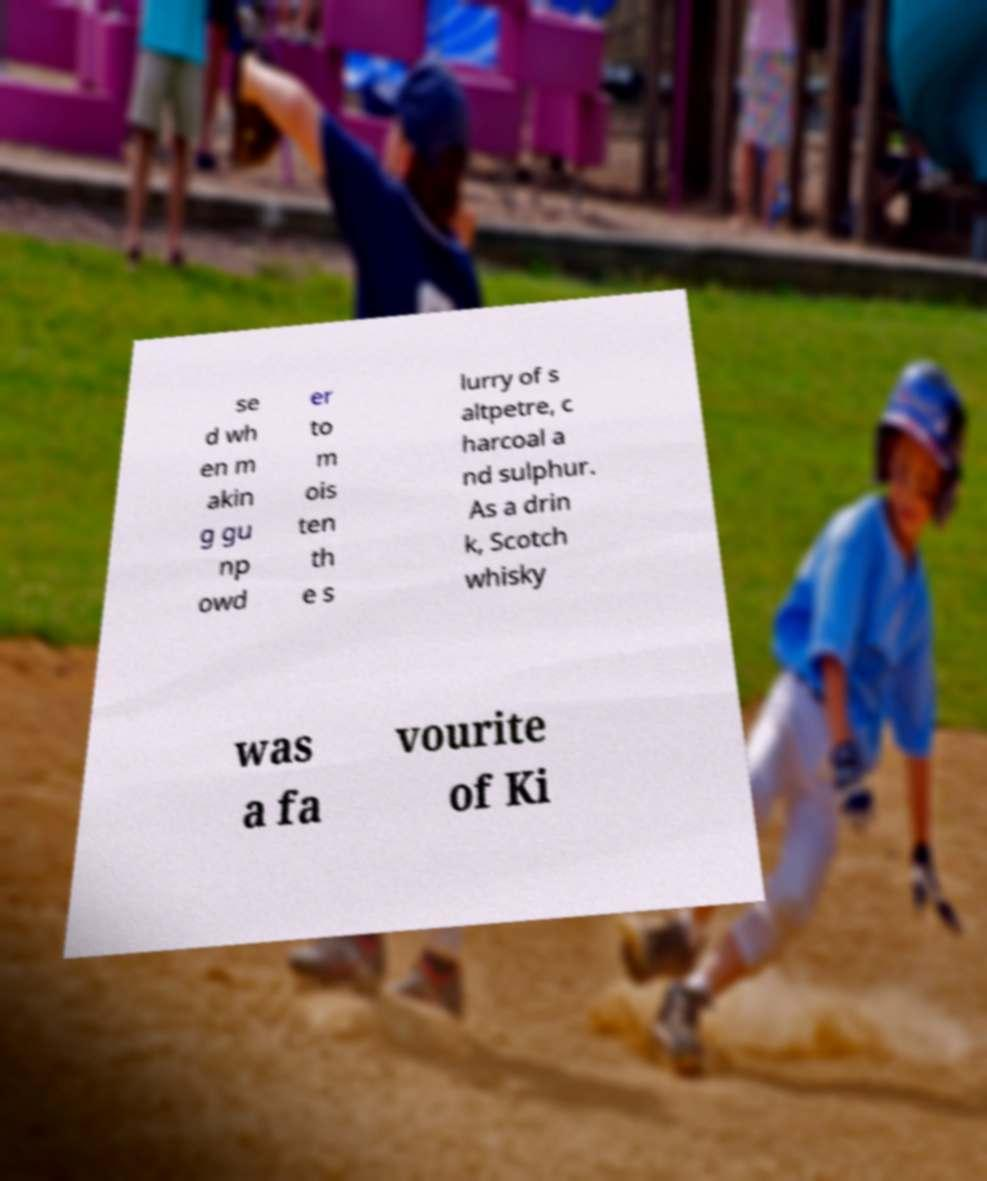What messages or text are displayed in this image? I need them in a readable, typed format. se d wh en m akin g gu np owd er to m ois ten th e s lurry of s altpetre, c harcoal a nd sulphur. As a drin k, Scotch whisky was a fa vourite of Ki 